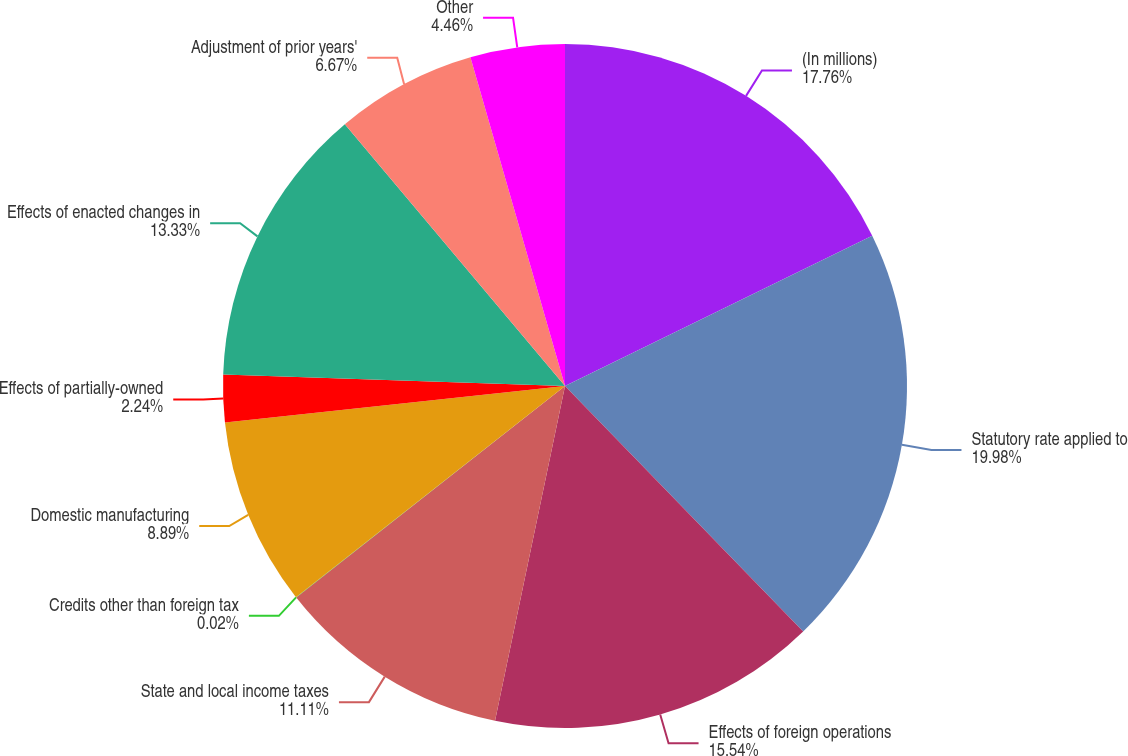<chart> <loc_0><loc_0><loc_500><loc_500><pie_chart><fcel>(In millions)<fcel>Statutory rate applied to<fcel>Effects of foreign operations<fcel>State and local income taxes<fcel>Credits other than foreign tax<fcel>Domestic manufacturing<fcel>Effects of partially-owned<fcel>Effects of enacted changes in<fcel>Adjustment of prior years'<fcel>Other<nl><fcel>17.76%<fcel>19.98%<fcel>15.54%<fcel>11.11%<fcel>0.02%<fcel>8.89%<fcel>2.24%<fcel>13.33%<fcel>6.67%<fcel>4.46%<nl></chart> 